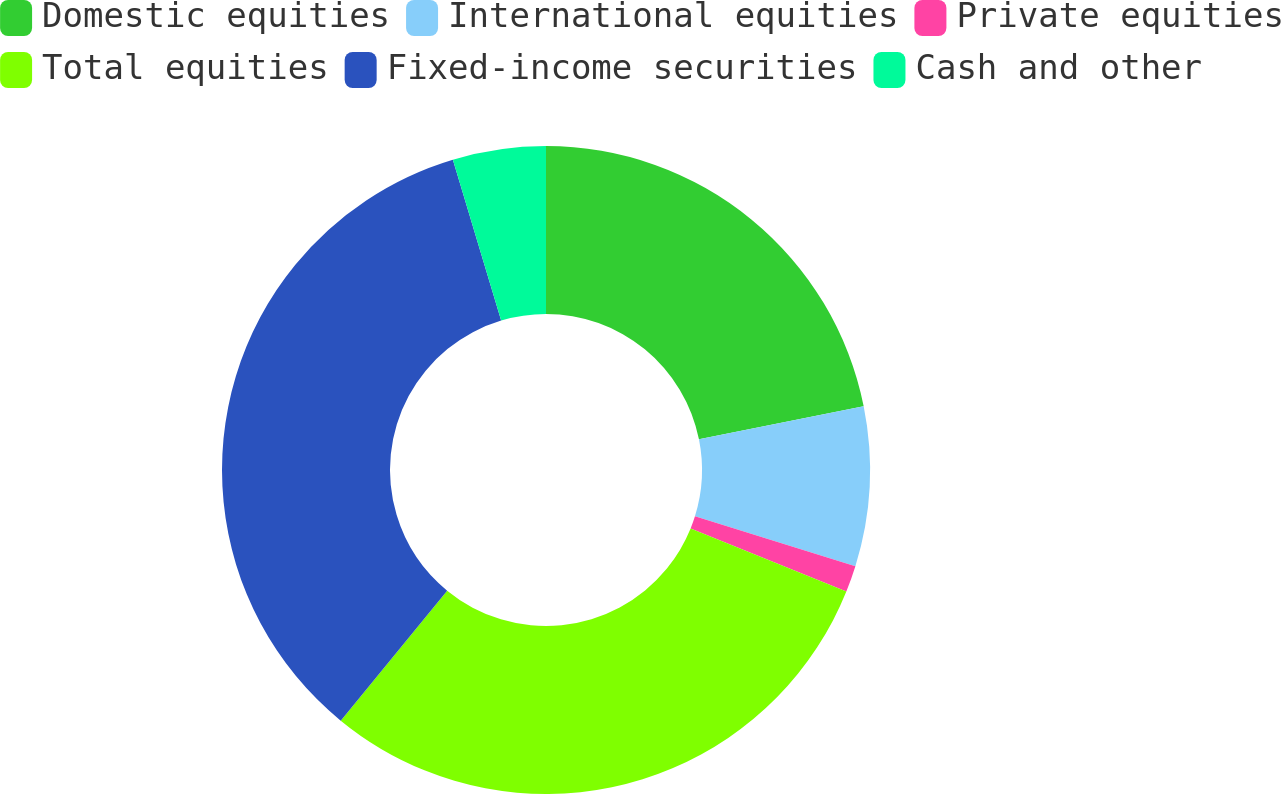Convert chart to OTSL. <chart><loc_0><loc_0><loc_500><loc_500><pie_chart><fcel>Domestic equities<fcel>International equities<fcel>Private equities<fcel>Total equities<fcel>Fixed-income securities<fcel>Cash and other<nl><fcel>21.85%<fcel>7.95%<fcel>1.32%<fcel>29.8%<fcel>34.44%<fcel>4.64%<nl></chart> 